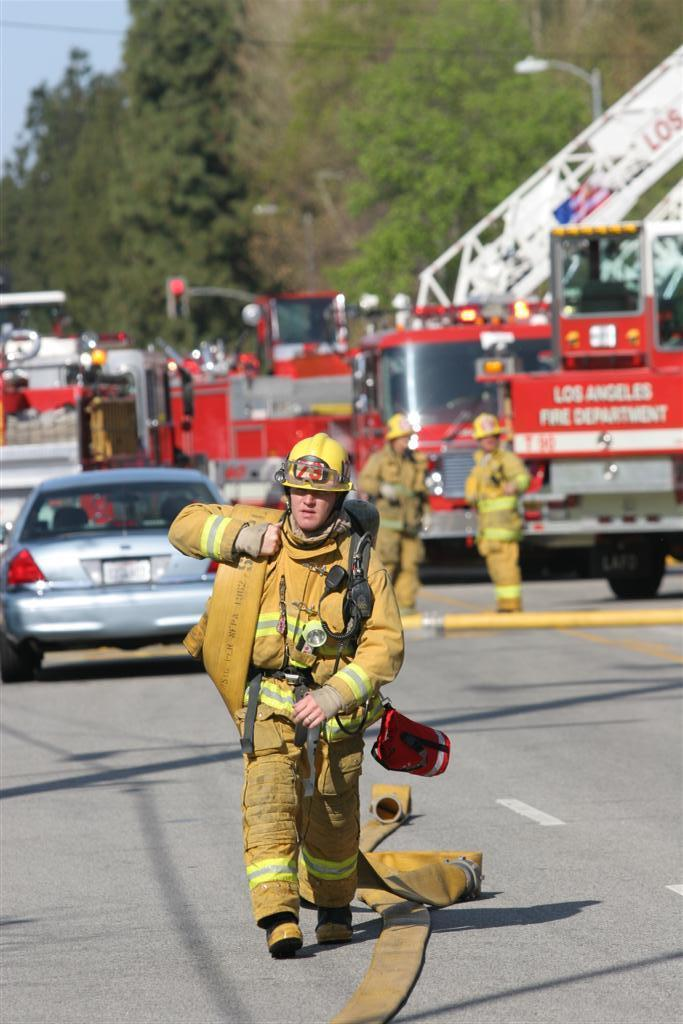Provide a one-sentence caption for the provided image. A firefighter in yellow in front of a vehicle reading Los Angeles Fire Department. 